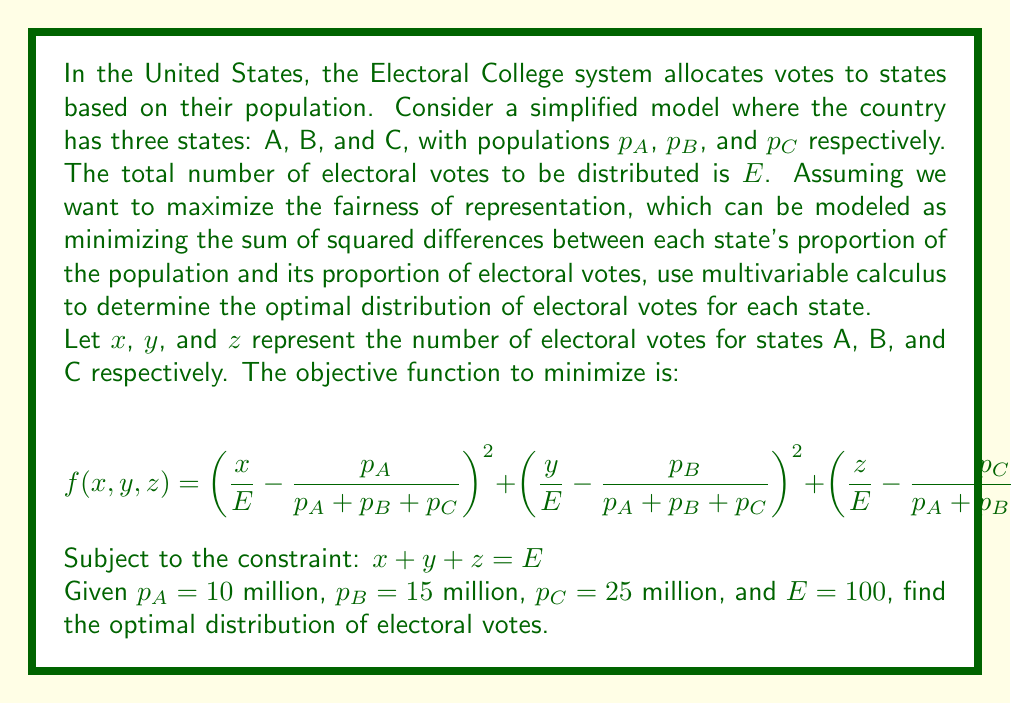Provide a solution to this math problem. To solve this optimization problem, we'll use the method of Lagrange multipliers:

1) First, let's simplify our notation. Let $P = p_A + p_B + p_C = 50$ million.

2) Our Lagrangian function is:

   $$L(x,y,z,\lambda) = \left(\frac{x}{E} - \frac{p_A}{P}\right)^2 + \left(\frac{y}{E} - \frac{p_B}{P}\right)^2 + \left(\frac{z}{E} - \frac{p_C}{P}\right)^2 + \lambda(x+y+z-E)$$

3) We now take partial derivatives and set them equal to zero:

   $$\frac{\partial L}{\partial x} = 2\left(\frac{x}{E} - \frac{p_A}{P}\right)\frac{1}{E} + \lambda = 0$$
   $$\frac{\partial L}{\partial y} = 2\left(\frac{y}{E} - \frac{p_B}{P}\right)\frac{1}{E} + \lambda = 0$$
   $$\frac{\partial L}{\partial z} = 2\left(\frac{z}{E} - \frac{p_C}{P}\right)\frac{1}{E} + \lambda = 0$$
   $$\frac{\partial L}{\partial \lambda} = x + y + z - E = 0$$

4) From the first three equations:

   $$x = \frac{p_A}{P}E - \frac{\lambda E}{2}$$
   $$y = \frac{p_B}{P}E - \frac{\lambda E}{2}$$
   $$z = \frac{p_C}{P}E - \frac{\lambda E}{2}$$

5) Substituting these into the fourth equation:

   $$\left(\frac{p_A}{P}E - \frac{\lambda E}{2}\right) + \left(\frac{p_B}{P}E - \frac{\lambda E}{2}\right) + \left(\frac{p_C}{P}E - \frac{\lambda E}{2}\right) = E$$

6) Simplifying:

   $$\frac{p_A+p_B+p_C}{P}E - \frac{3\lambda E}{2} = E$$
   $$1 - \frac{3\lambda E}{2} = 1$$
   $$\lambda = 0$$

7) Therefore, the optimal distribution is:

   $$x = \frac{p_A}{P}E = \frac{10}{50}100 = 20$$
   $$y = \frac{p_B}{P}E = \frac{15}{50}100 = 30$$
   $$z = \frac{p_C}{P}E = \frac{25}{50}100 = 50$$

This solution shows that the optimal distribution of electoral votes is directly proportional to each state's population.
Answer: The optimal distribution of electoral votes is:
State A: 20 votes
State B: 30 votes
State C: 50 votes 